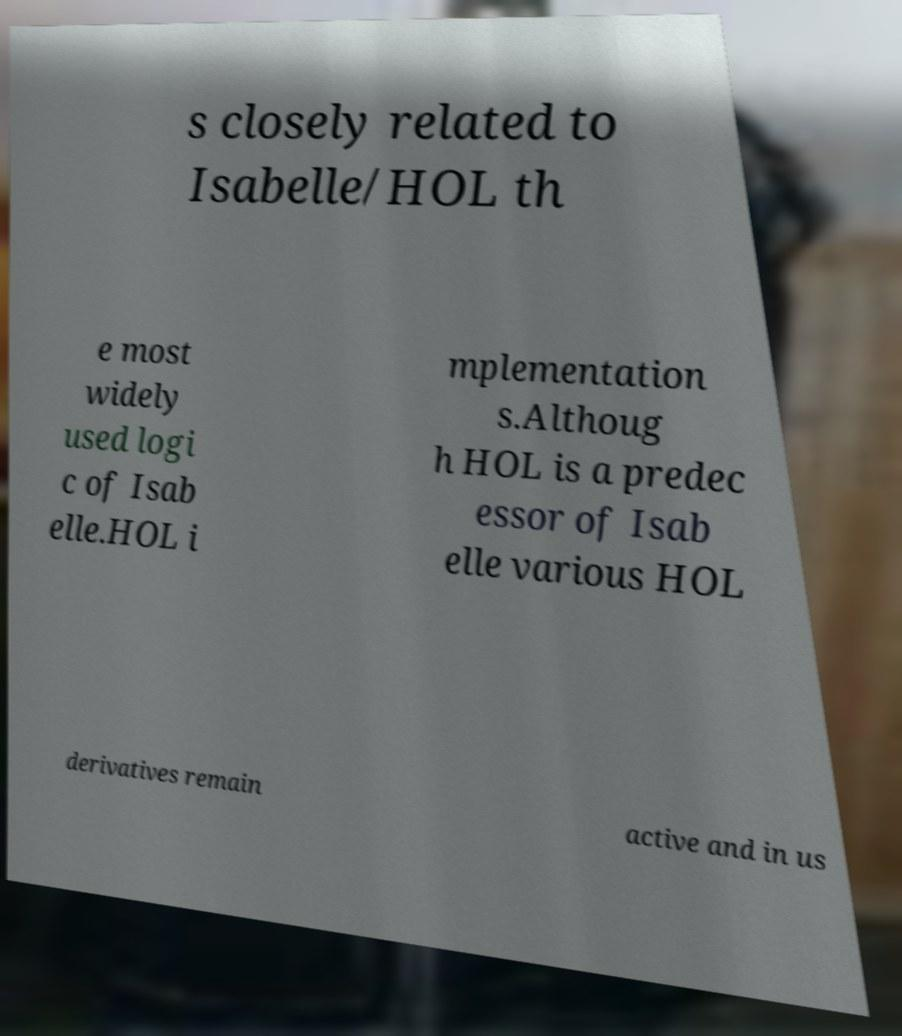What messages or text are displayed in this image? I need them in a readable, typed format. s closely related to Isabelle/HOL th e most widely used logi c of Isab elle.HOL i mplementation s.Althoug h HOL is a predec essor of Isab elle various HOL derivatives remain active and in us 